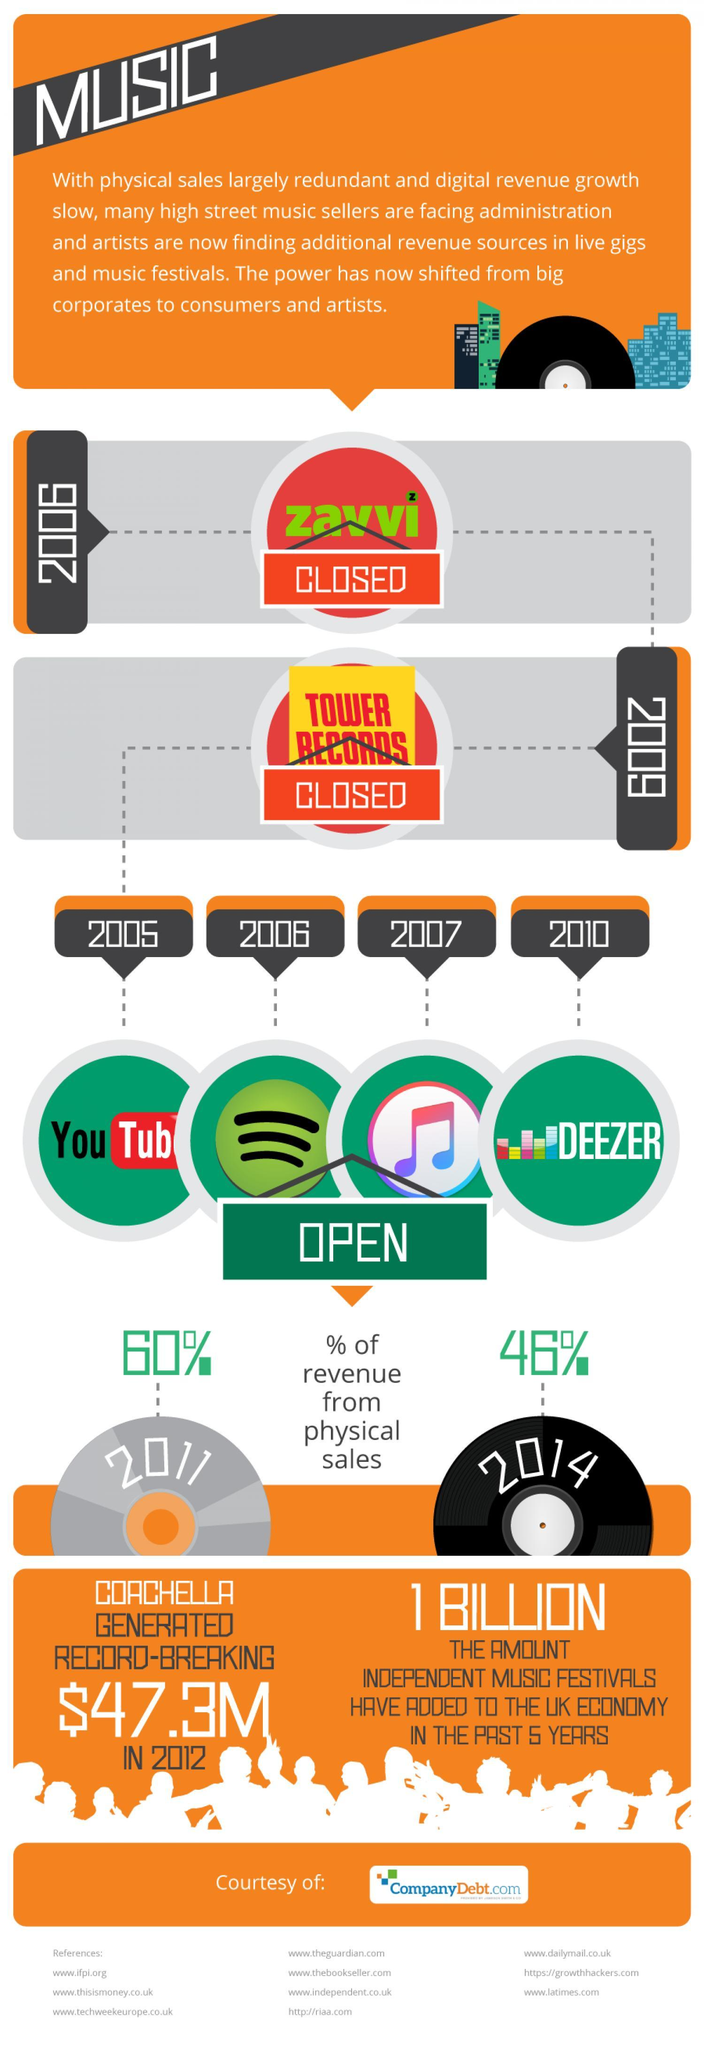What was the percentage reduction in physical sales during 2011 to 2014?
Answer the question with a short phrase. 14% In which year was music seller Tower records closed? 2009 In which year was music seller Zavvi closed? 2006 Which online music streaming service opened the business 2006, Youtube music, Deezer, or Spotify? Spotify Which music sellers shut shop between the period 2006-2009? Zavvi, Tower records 